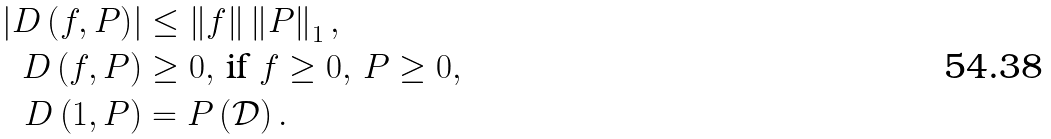Convert formula to latex. <formula><loc_0><loc_0><loc_500><loc_500>\left | D \left ( f , P \right ) \right | & \leq \left \| f \right \| \left \| P \right \| _ { 1 } , \\ D \left ( f , P \right ) & \geq 0 , \, \text {if } f \geq 0 , \, P \geq 0 , \\ D \left ( 1 , P \right ) & = P \left ( \mathcal { D } \right ) .</formula> 